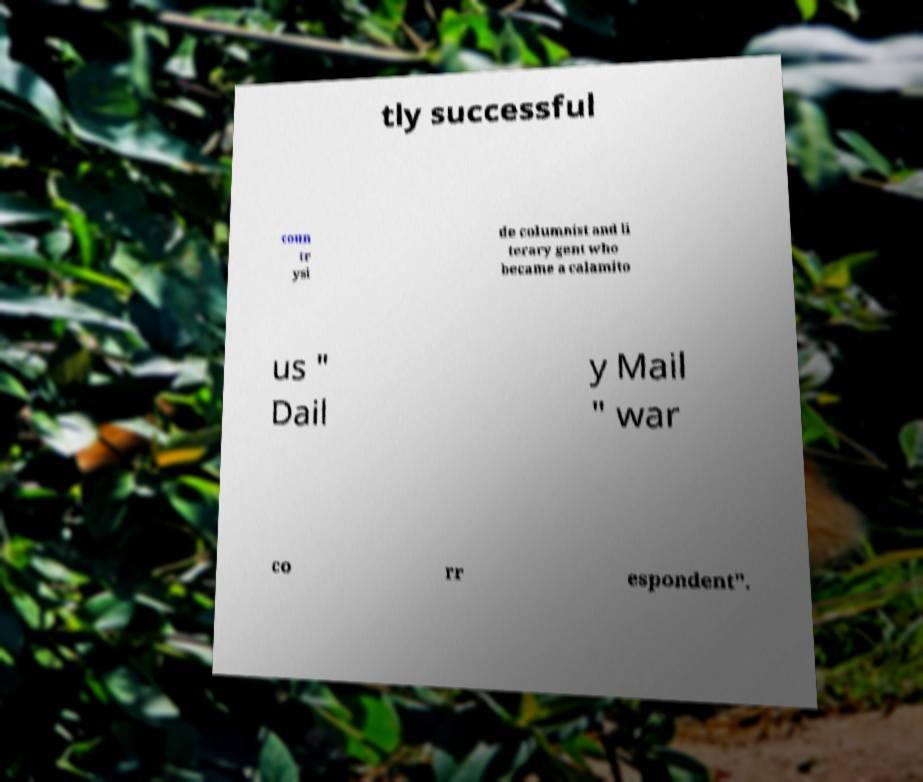Can you read and provide the text displayed in the image?This photo seems to have some interesting text. Can you extract and type it out for me? tly successful coun tr ysi de columnist and li terary gent who became a calamito us " Dail y Mail " war co rr espondent". 